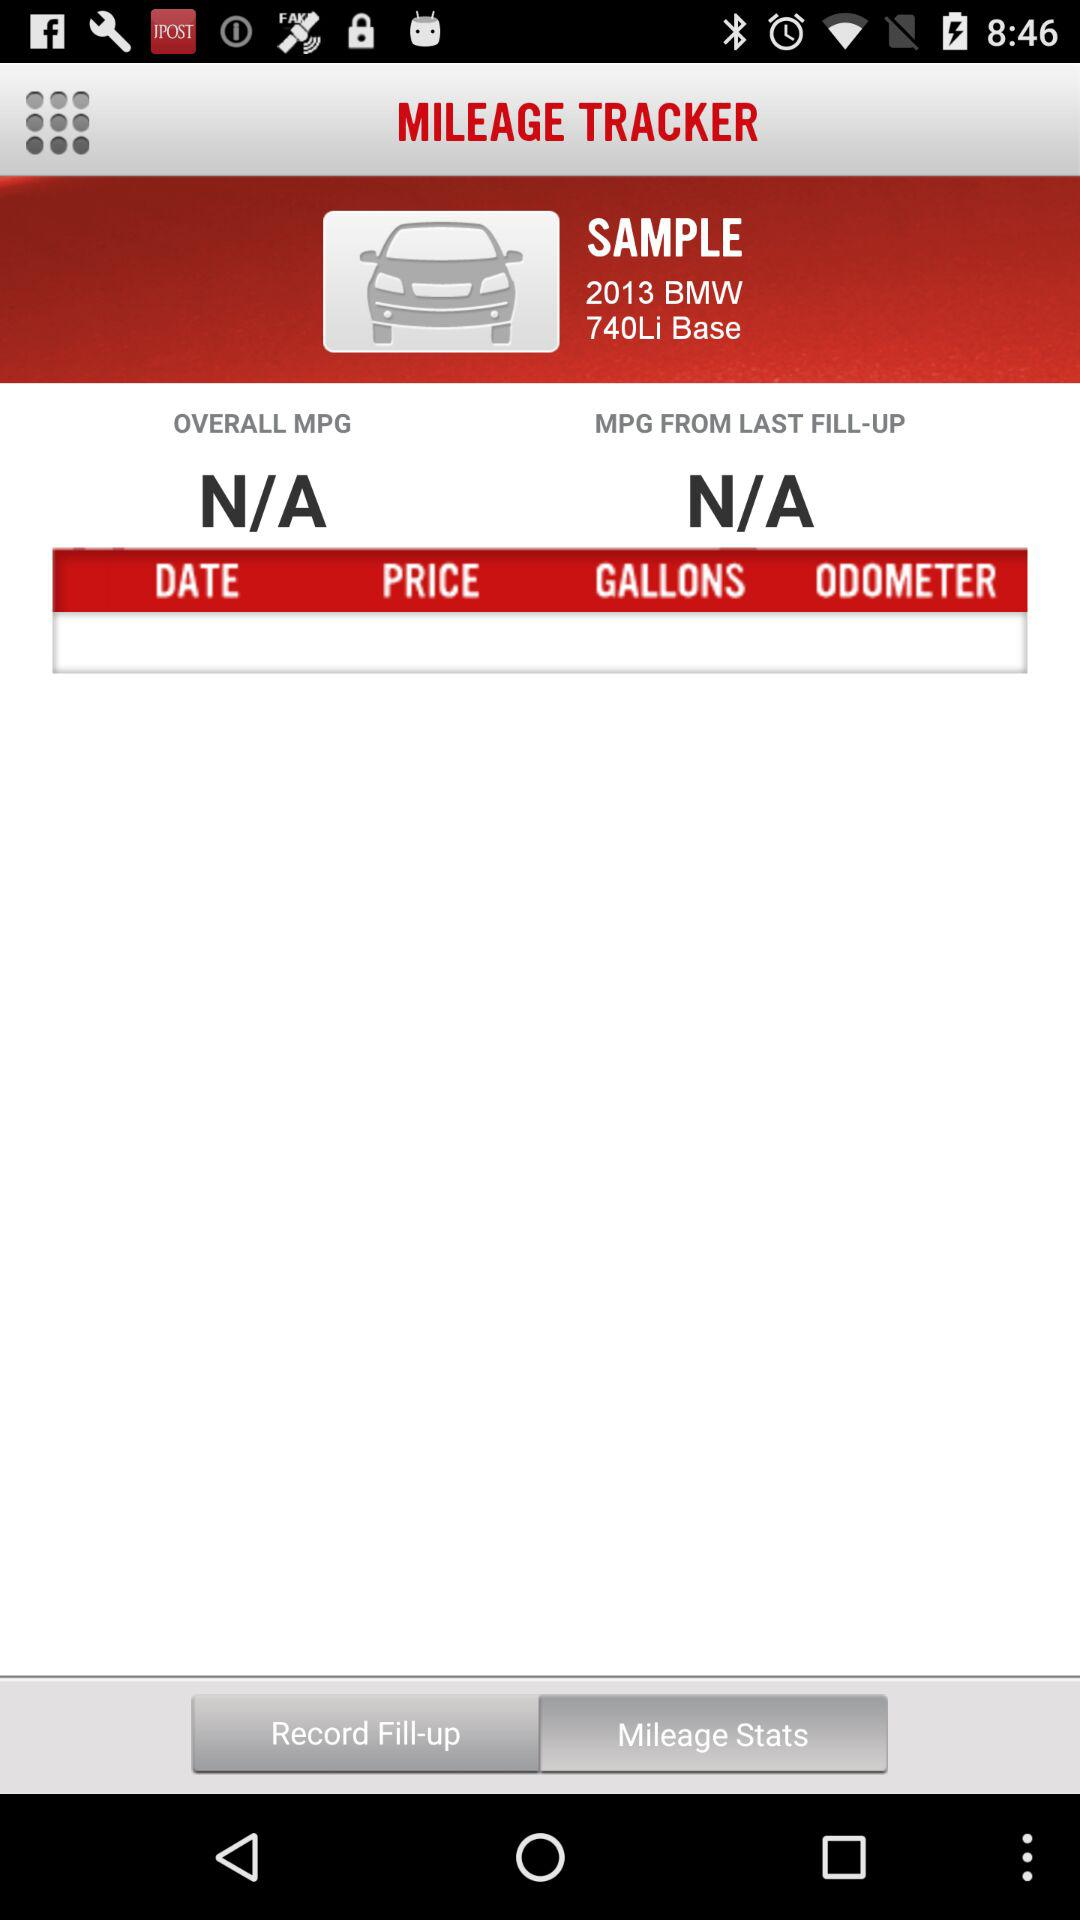What are the car sample details? The car sample details are "2013 BMW 740Li Base". 